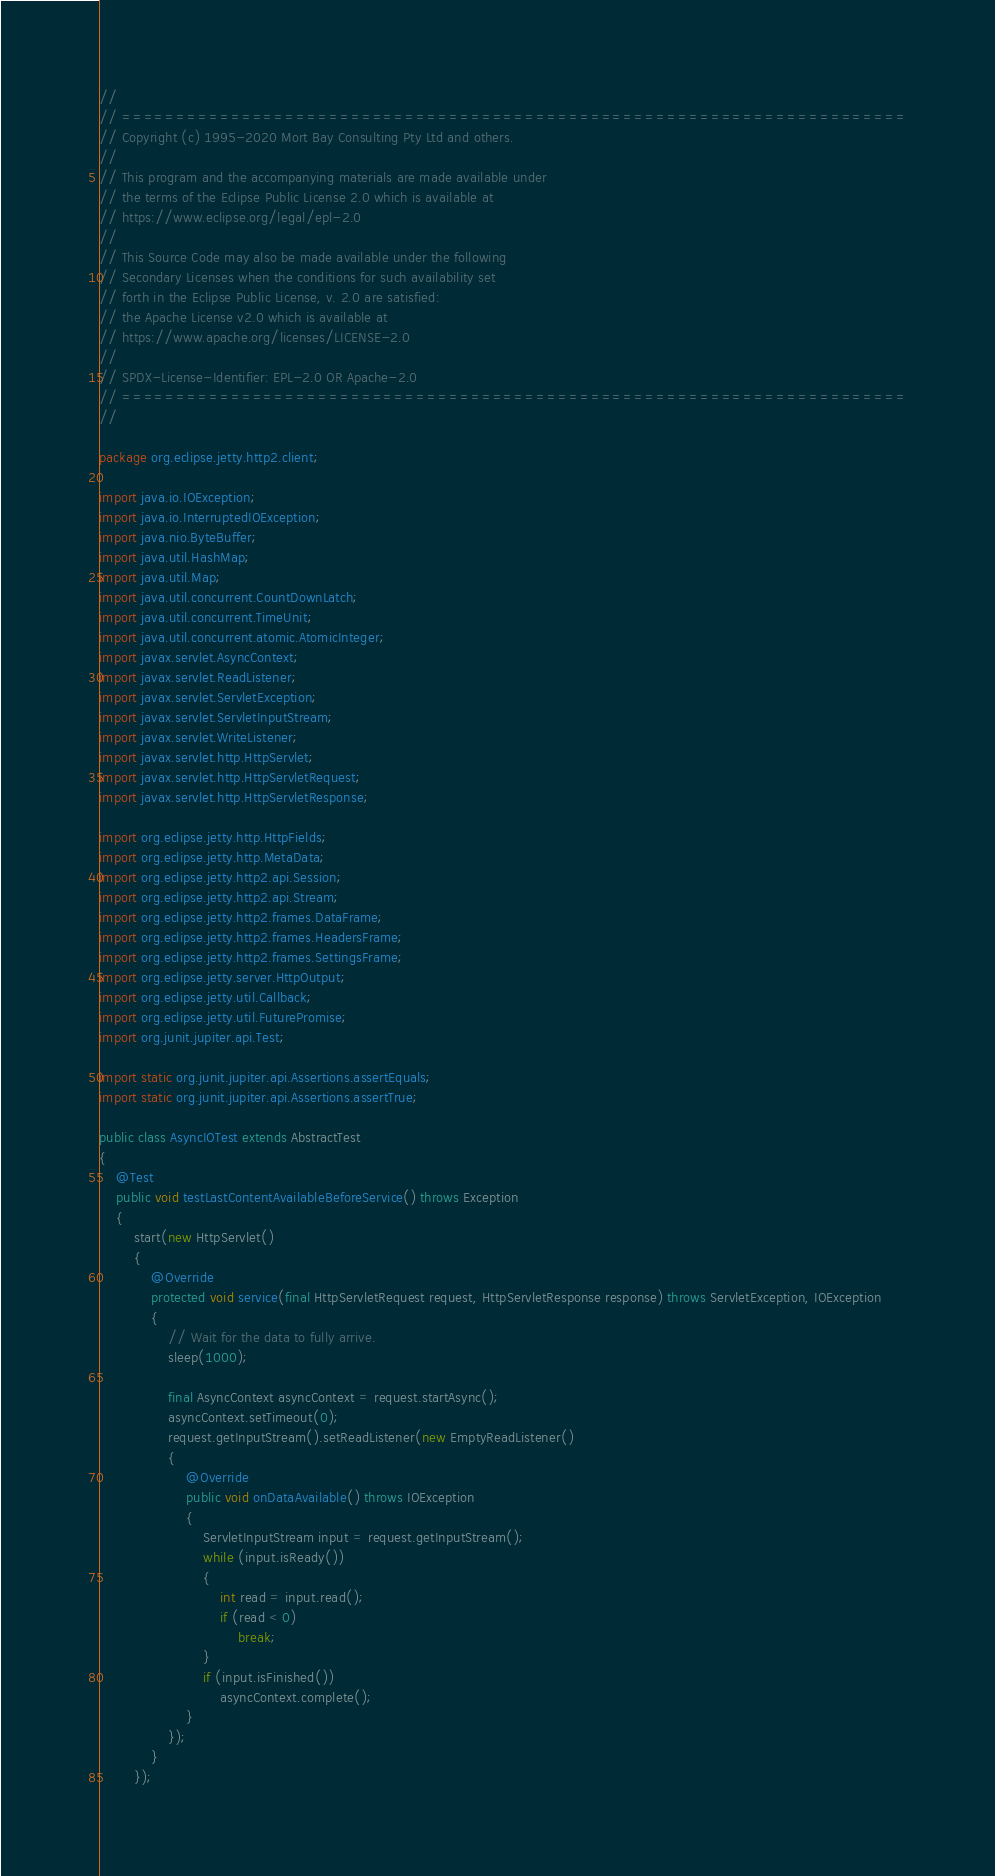Convert code to text. <code><loc_0><loc_0><loc_500><loc_500><_Java_>//
// ========================================================================
// Copyright (c) 1995-2020 Mort Bay Consulting Pty Ltd and others.
//
// This program and the accompanying materials are made available under
// the terms of the Eclipse Public License 2.0 which is available at
// https://www.eclipse.org/legal/epl-2.0
//
// This Source Code may also be made available under the following
// Secondary Licenses when the conditions for such availability set
// forth in the Eclipse Public License, v. 2.0 are satisfied:
// the Apache License v2.0 which is available at
// https://www.apache.org/licenses/LICENSE-2.0
//
// SPDX-License-Identifier: EPL-2.0 OR Apache-2.0
// ========================================================================
//

package org.eclipse.jetty.http2.client;

import java.io.IOException;
import java.io.InterruptedIOException;
import java.nio.ByteBuffer;
import java.util.HashMap;
import java.util.Map;
import java.util.concurrent.CountDownLatch;
import java.util.concurrent.TimeUnit;
import java.util.concurrent.atomic.AtomicInteger;
import javax.servlet.AsyncContext;
import javax.servlet.ReadListener;
import javax.servlet.ServletException;
import javax.servlet.ServletInputStream;
import javax.servlet.WriteListener;
import javax.servlet.http.HttpServlet;
import javax.servlet.http.HttpServletRequest;
import javax.servlet.http.HttpServletResponse;

import org.eclipse.jetty.http.HttpFields;
import org.eclipse.jetty.http.MetaData;
import org.eclipse.jetty.http2.api.Session;
import org.eclipse.jetty.http2.api.Stream;
import org.eclipse.jetty.http2.frames.DataFrame;
import org.eclipse.jetty.http2.frames.HeadersFrame;
import org.eclipse.jetty.http2.frames.SettingsFrame;
import org.eclipse.jetty.server.HttpOutput;
import org.eclipse.jetty.util.Callback;
import org.eclipse.jetty.util.FuturePromise;
import org.junit.jupiter.api.Test;

import static org.junit.jupiter.api.Assertions.assertEquals;
import static org.junit.jupiter.api.Assertions.assertTrue;

public class AsyncIOTest extends AbstractTest
{
    @Test
    public void testLastContentAvailableBeforeService() throws Exception
    {
        start(new HttpServlet()
        {
            @Override
            protected void service(final HttpServletRequest request, HttpServletResponse response) throws ServletException, IOException
            {
                // Wait for the data to fully arrive.
                sleep(1000);

                final AsyncContext asyncContext = request.startAsync();
                asyncContext.setTimeout(0);
                request.getInputStream().setReadListener(new EmptyReadListener()
                {
                    @Override
                    public void onDataAvailable() throws IOException
                    {
                        ServletInputStream input = request.getInputStream();
                        while (input.isReady())
                        {
                            int read = input.read();
                            if (read < 0)
                                break;
                        }
                        if (input.isFinished())
                            asyncContext.complete();
                    }
                });
            }
        });
</code> 